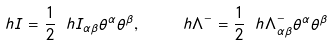Convert formula to latex. <formula><loc_0><loc_0><loc_500><loc_500>\ h { I } = \frac { 1 } { 2 } \ h { I } _ { \alpha \beta } \theta ^ { \alpha } \theta ^ { \beta } , \quad \ h { \Lambda } ^ { - } = \frac { 1 } { 2 } \ h { \Lambda } ^ { - } _ { \alpha \beta } \theta ^ { \alpha } \theta ^ { \beta }</formula> 